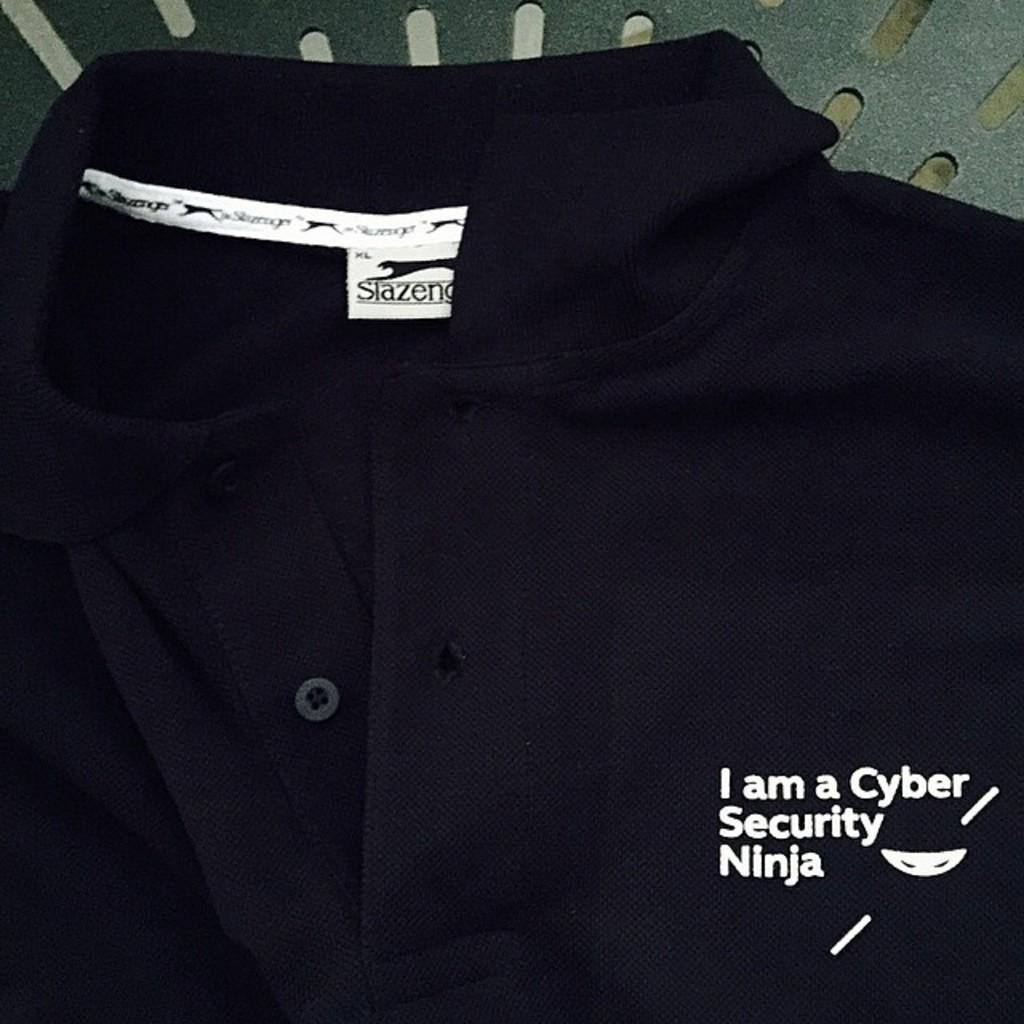What type of clothing item is in the image? There is a t-shirt in the image. What is written or printed on the t-shirt? The t-shirt has text on it. Is there any symbol or design on the t-shirt? Yes, the t-shirt has a logo on it. Can you describe the background of the image? There is an object in the background of the image. What type of education can be seen in the image? There is no reference to education in the image; it features a t-shirt with text and a logo. How many dolls are visible in the image? There are no dolls present in the image. 